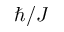<formula> <loc_0><loc_0><loc_500><loc_500>\hbar { / } J</formula> 